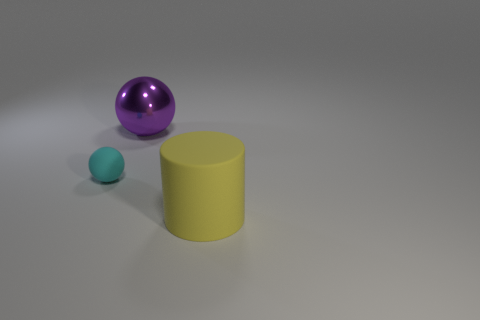Add 2 brown metallic spheres. How many objects exist? 5 Subtract all cylinders. How many objects are left? 2 Add 1 tiny cyan balls. How many tiny cyan balls exist? 2 Subtract 0 purple cubes. How many objects are left? 3 Subtract all large green metal balls. Subtract all yellow rubber objects. How many objects are left? 2 Add 2 metallic balls. How many metallic balls are left? 3 